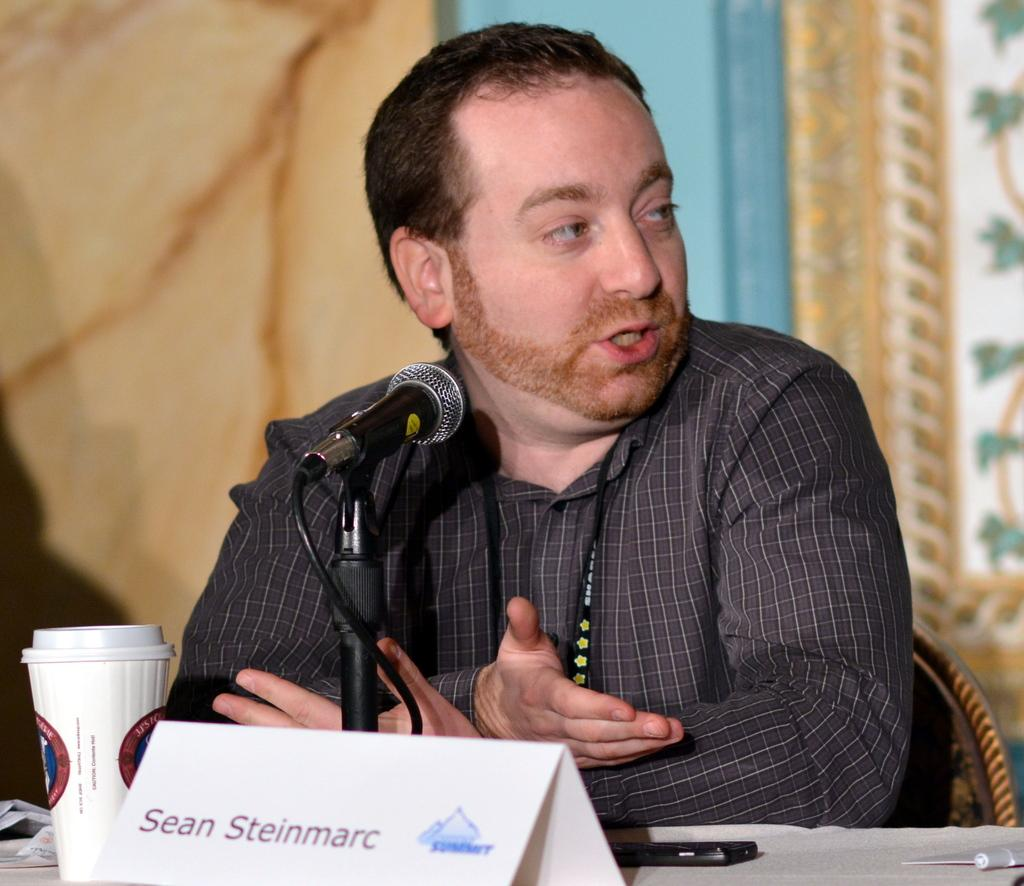Who is the person in the image? There is a man in the image. What is the man doing in the image? The man is seated on a chair. What objects are in front of the man? There is a microphone, a cup, a name board, and a mobile in front of the man. What else can be seen on the table in the image? There are other things on the table. What type of wax is being used to create the name board in the image? There is no wax present in the image, and the name board is not mentioned as being made of wax. 